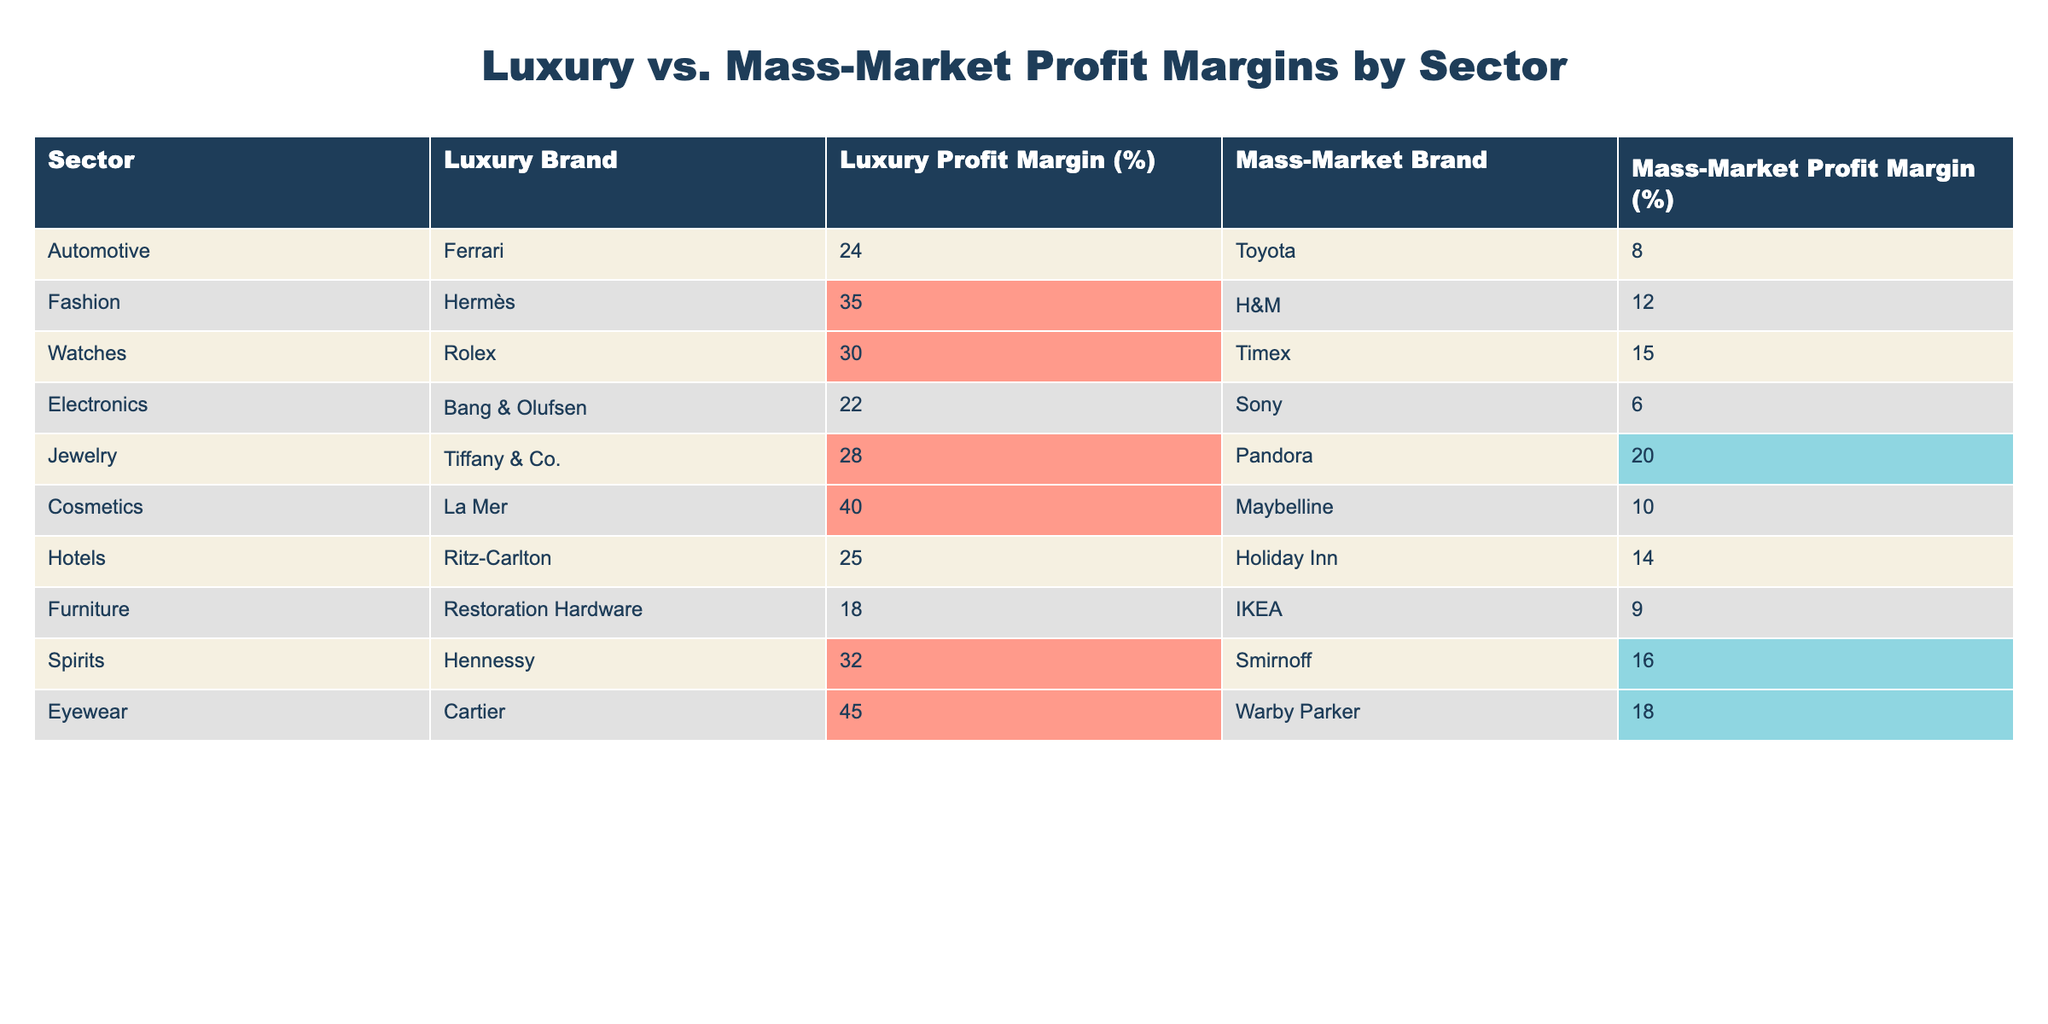What is the profit margin percentage of the luxury brand in the fashion sector? The table indicates that the luxury brand in the fashion sector is Hermès, which has a profit margin of 35%.
Answer: 35% Which mass-market brand has the highest profit margin, and what is that percentage? According to the table, the mass-market brand with the highest profit margin is H&M at 12%.
Answer: H&M, 12% What is the difference in profit margins between the luxury and mass-market brands in the automotive sector? For the automotive sector, Ferrari has a profit margin of 24%, while Toyota has 8%. The difference is 24% - 8% = 16%.
Answer: 16% Is the profit margin for the luxury brand in cosmetics greater than that for the mass-market brand in the same sector? La Mer has a profit margin of 40%, while Maybelline has a profit margin of 10%. Since 40% is greater than 10%, the answer is yes.
Answer: Yes What is the average profit margin for luxury brands across all sectors in the table? To find the average for luxury brands, sum their profit margins: 24 + 35 + 30 + 22 + 28 + 40 + 25 + 18 + 32 + 45 =  304. There are 10 luxury brands, so the average is 304 / 10 = 30.4%.
Answer: 30.4% Which sector shows the largest difference in profit margins between luxury and mass-market brands? To find the largest difference, compare the differences calculated for each sector. The differences are: Automotive (16), Fashion (23), Watches (15), Electronics (16), Jewelry (8), Cosmetics (30), Hotels (11), Furniture (9), Spirits (16), Eyewear (27). The largest difference is in the cosmetics sector with 30%.
Answer: Cosmetics, 30% Are profit margins for mass-market brands in watches and spirits equal or not? The profit margin for Timex (mass-market watch) is 15% and for Smirnoff (mass-market spirit) is 16%. Since 15% is not equal to 16%, the answer is no.
Answer: No What is the total profit margin for mass-market brands across all sectors? The total is calculated by summing the profit margins for mass-market brands: 8 + 12 + 15 + 6 + 20 + 10 + 14 + 9 + 16 + 18 = 128%.
Answer: 128% Which luxury brand has the lowest profit margin and what is that percentage? Observing the table, the luxury brand with the lowest profit margin is Restoration Hardware at 18%.
Answer: Restoration Hardware, 18% 